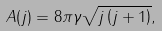Convert formula to latex. <formula><loc_0><loc_0><loc_500><loc_500>A ( j ) = 8 \pi \gamma \sqrt { j \left ( j + 1 \right ) } ,</formula> 